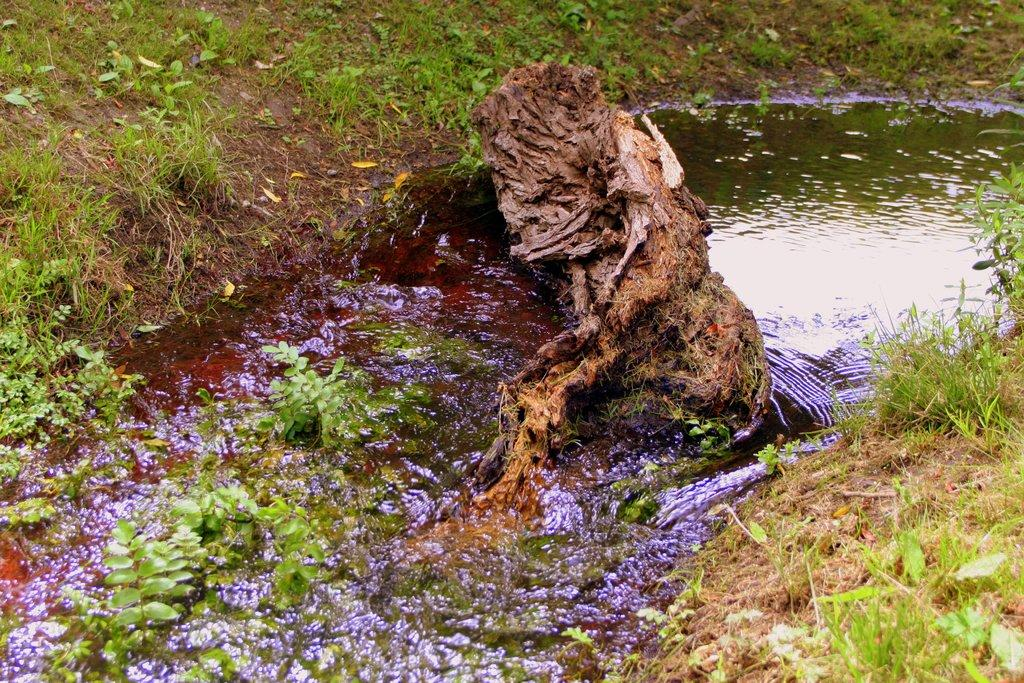What is the main feature of the image? There is a river flowing in the image. What can be found in the river? Bark and plants are present in the river. What type of vegetation is visible on the riverbanks? Grass is present on both sides of the river. What type of chain can be seen connecting the plants in the river? There is no chain present in the image; the plants are not connected by any visible chain. 